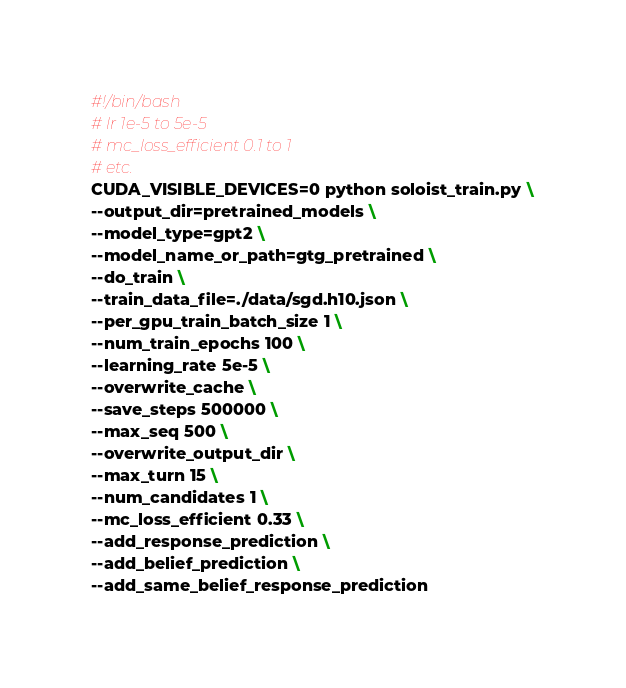<code> <loc_0><loc_0><loc_500><loc_500><_Bash_>#!/bin/bash
# lr 1e-5 to 5e-5
# mc_loss_efficient 0.1 to 1
# etc.
CUDA_VISIBLE_DEVICES=0 python soloist_train.py \
--output_dir=pretrained_models \
--model_type=gpt2 \
--model_name_or_path=gtg_pretrained \
--do_train \
--train_data_file=./data/sgd.h10.json \
--per_gpu_train_batch_size 1 \
--num_train_epochs 100 \
--learning_rate 5e-5 \
--overwrite_cache \
--save_steps 500000 \
--max_seq 500 \
--overwrite_output_dir \
--max_turn 15 \
--num_candidates 1 \
--mc_loss_efficient 0.33 \
--add_response_prediction \
--add_belief_prediction \
--add_same_belief_response_prediction
</code> 